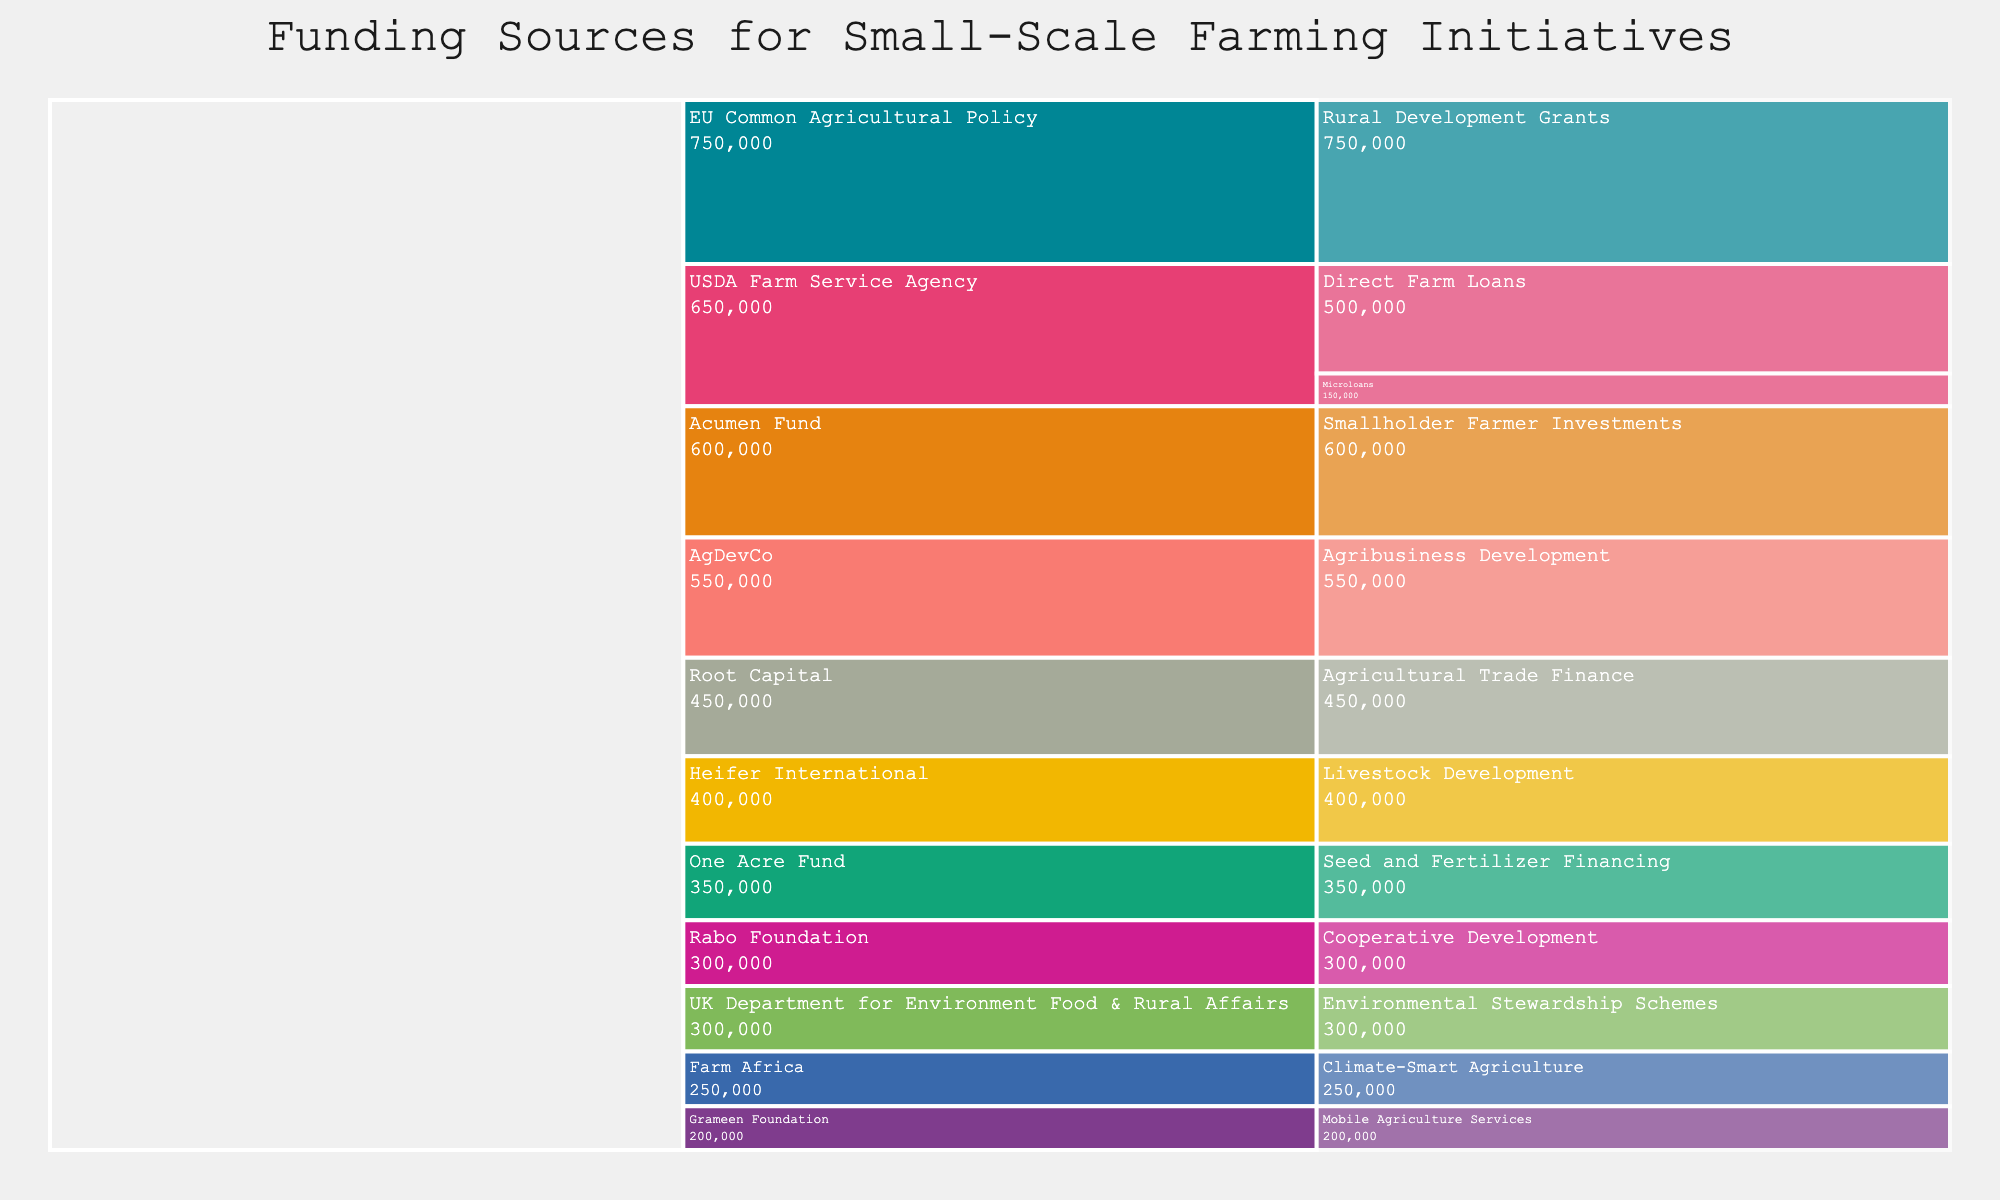What is the title of the chart? The chart title is usually prominent and provides an overview of the figure's purpose. Here, the title can be found at the top center of the chart.
Answer: Funding Sources for Small-Scale Farming Initiatives How much funding is provided by the USDA Farm Service Agency in total? Sum the funding amounts for the subcategories under USDA Farm Service Agency: Direct Farm Loans ($500,000) and Microloans ($150,000). Adding these amounts gives the total.
Answer: $650,000 Which category has the highest total funding? Sum the funding amounts for each major category: Government Programs, NGOs, and Private Investments. Compare the totals to find the category with the highest funding.
Answer: Government Programs What is the difference in funding between Government Programs and NGOs? Calculate the total funds for Government Programs and NGOs, then subtract the total funding for NGOs from the total for Government Programs.
Answer: $800,000 Which subcategory within NGOs received the highest funding? Compare the funding amounts of all subcategories under NGOs: Heifer International ($400,000), One Acre Fund ($350,000), Farm Africa ($250,000), Grameen Foundation ($200,000). Identify the highest value.
Answer: Heifer International What is the combined amount of funding from Environmental Stewardship Schemes and Livestock Development? Sum the funding amounts from Environmental Stewardship Schemes ($300,000) and Livestock Development ($400,000). Adding these gives the total.
Answer: $700,000 How does the funding of Mobile Agriculture Services compare to Cooperative Development? Compare the funding amounts of Mobile Agriculture Services ($200,000) and Cooperative Development ($300,000) to determine which is higher and by how much.
Answer: $100,000 less Which subcategory within Private Investments has the lowest funding? Compare the funding amounts for subcategories under Private Investments: Acumen Fund ($600,000), Root Capital ($450,000), AgDevCo ($550,000), Rabo Foundation ($300,000). Identify the lowest.
Answer: Rabo Foundation What is the average funding amount for the subcategories under Government Programs? Sum the funding amounts of all subcategories under Government Programs: Direct Farm Loans ($500,000), Microloans ($150,000), Rural Development Grants ($750,000), Environmental Stewardship Schemes ($300,000). Divide the total by the number of subcategories (4).
Answer: $425,000 Which category has the most diverse range of funding amounts? Examine the range (difference between the highest and lowest values) of funding amounts within each category and compare them to find where the diversity is greatest.
Answer: NGOs 